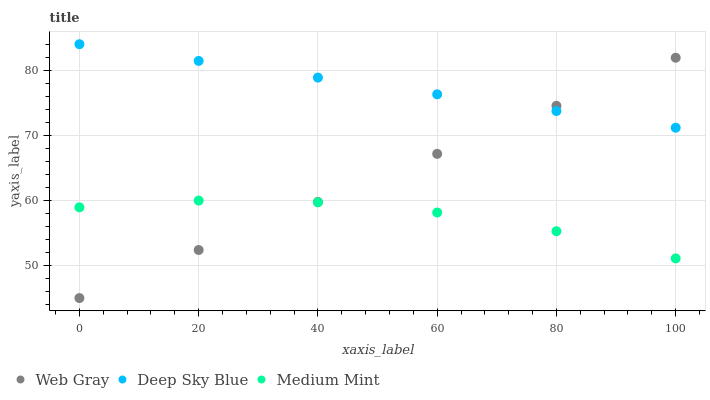Does Medium Mint have the minimum area under the curve?
Answer yes or no. Yes. Does Deep Sky Blue have the maximum area under the curve?
Answer yes or no. Yes. Does Web Gray have the minimum area under the curve?
Answer yes or no. No. Does Web Gray have the maximum area under the curve?
Answer yes or no. No. Is Deep Sky Blue the smoothest?
Answer yes or no. Yes. Is Medium Mint the roughest?
Answer yes or no. Yes. Is Web Gray the smoothest?
Answer yes or no. No. Is Web Gray the roughest?
Answer yes or no. No. Does Web Gray have the lowest value?
Answer yes or no. Yes. Does Deep Sky Blue have the lowest value?
Answer yes or no. No. Does Deep Sky Blue have the highest value?
Answer yes or no. Yes. Does Web Gray have the highest value?
Answer yes or no. No. Is Medium Mint less than Deep Sky Blue?
Answer yes or no. Yes. Is Deep Sky Blue greater than Medium Mint?
Answer yes or no. Yes. Does Deep Sky Blue intersect Web Gray?
Answer yes or no. Yes. Is Deep Sky Blue less than Web Gray?
Answer yes or no. No. Is Deep Sky Blue greater than Web Gray?
Answer yes or no. No. Does Medium Mint intersect Deep Sky Blue?
Answer yes or no. No. 